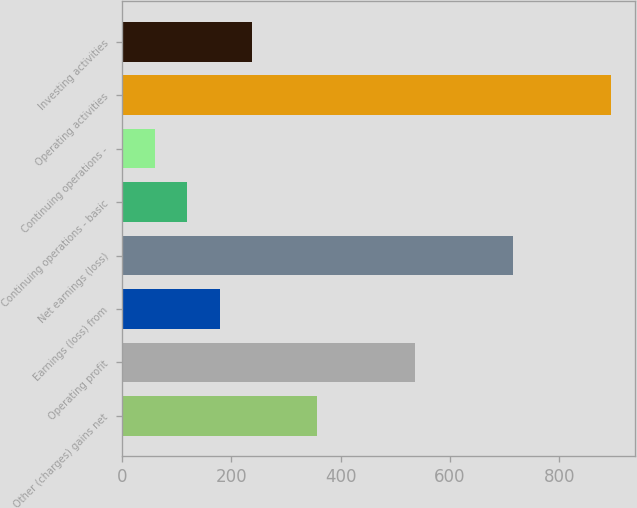<chart> <loc_0><loc_0><loc_500><loc_500><bar_chart><fcel>Other (charges) gains net<fcel>Operating profit<fcel>Earnings (loss) from<fcel>Net earnings (loss)<fcel>Continuing operations - basic<fcel>Continuing operations -<fcel>Operating activities<fcel>Investing activities<nl><fcel>357.64<fcel>536.38<fcel>178.9<fcel>715.12<fcel>119.32<fcel>59.74<fcel>893.86<fcel>238.48<nl></chart> 